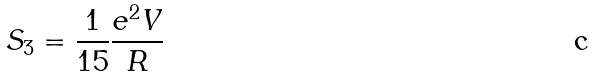Convert formula to latex. <formula><loc_0><loc_0><loc_500><loc_500>S _ { 3 } = \frac { 1 } { 1 5 } \frac { e ^ { 2 } V } { R }</formula> 